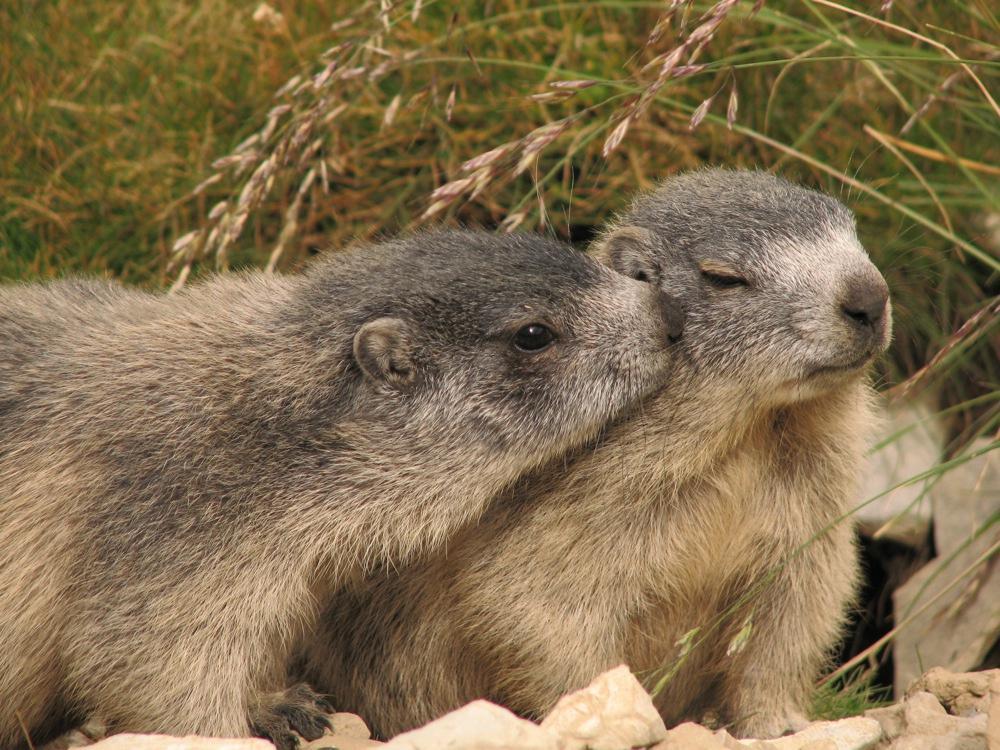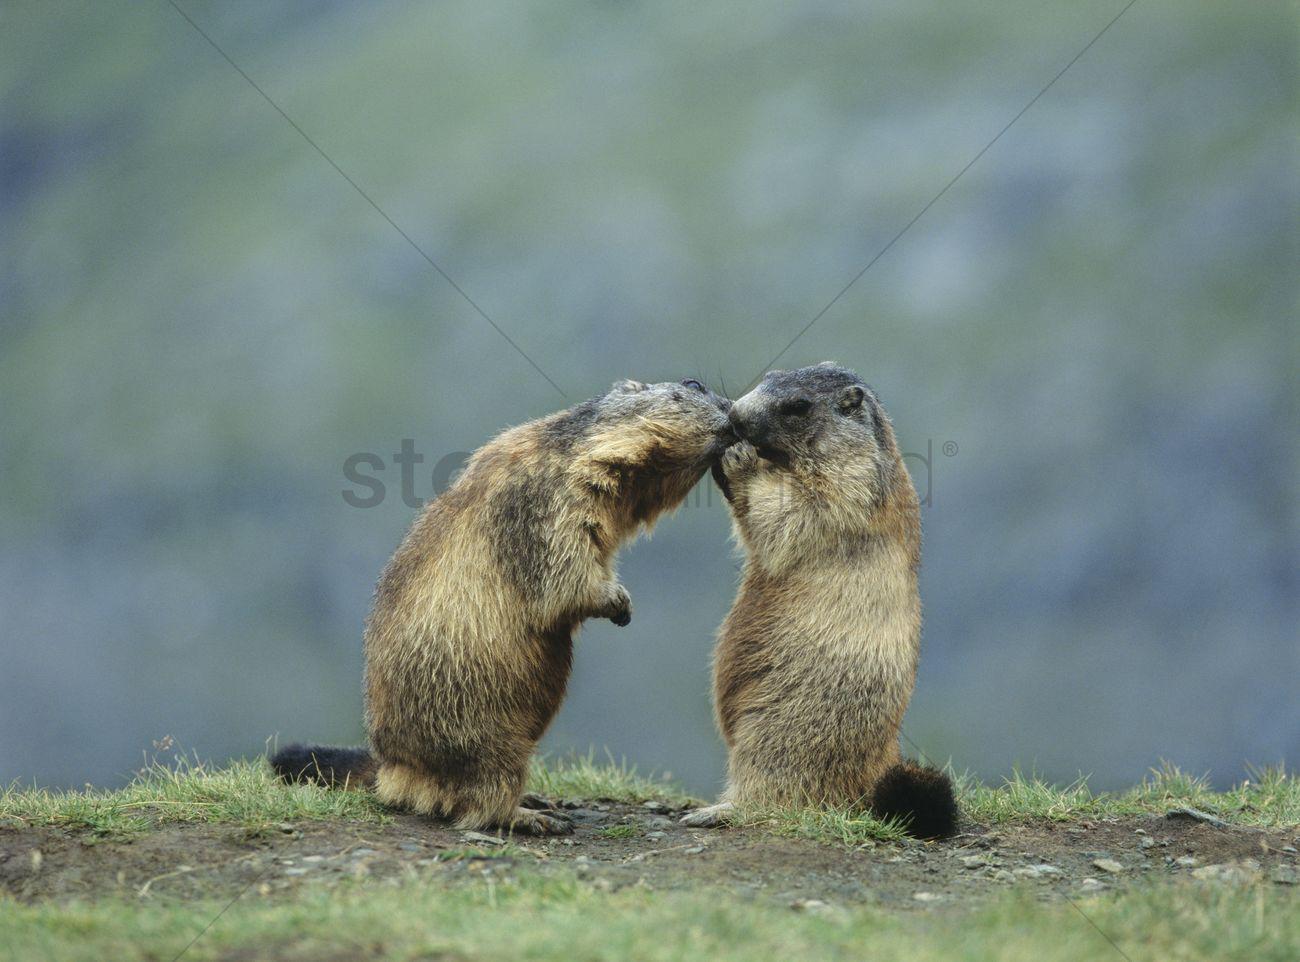The first image is the image on the left, the second image is the image on the right. Given the left and right images, does the statement "The marmots are touching in each image." hold true? Answer yes or no. Yes. The first image is the image on the left, the second image is the image on the right. Evaluate the accuracy of this statement regarding the images: "Two pairs of ground hogs are kissing.". Is it true? Answer yes or no. Yes. 